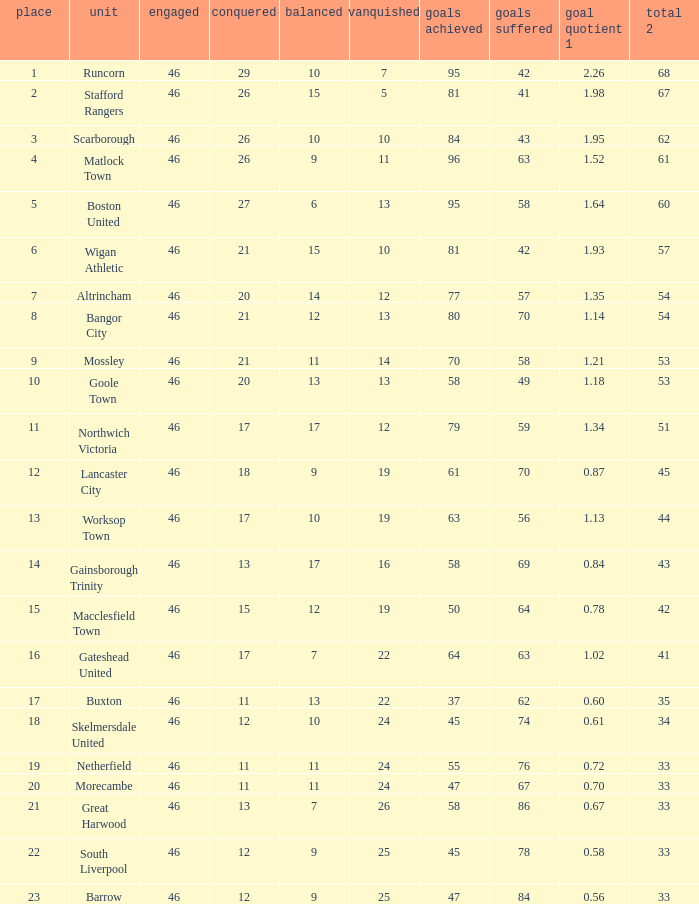How many times did the Lancaster City team play? 1.0. 